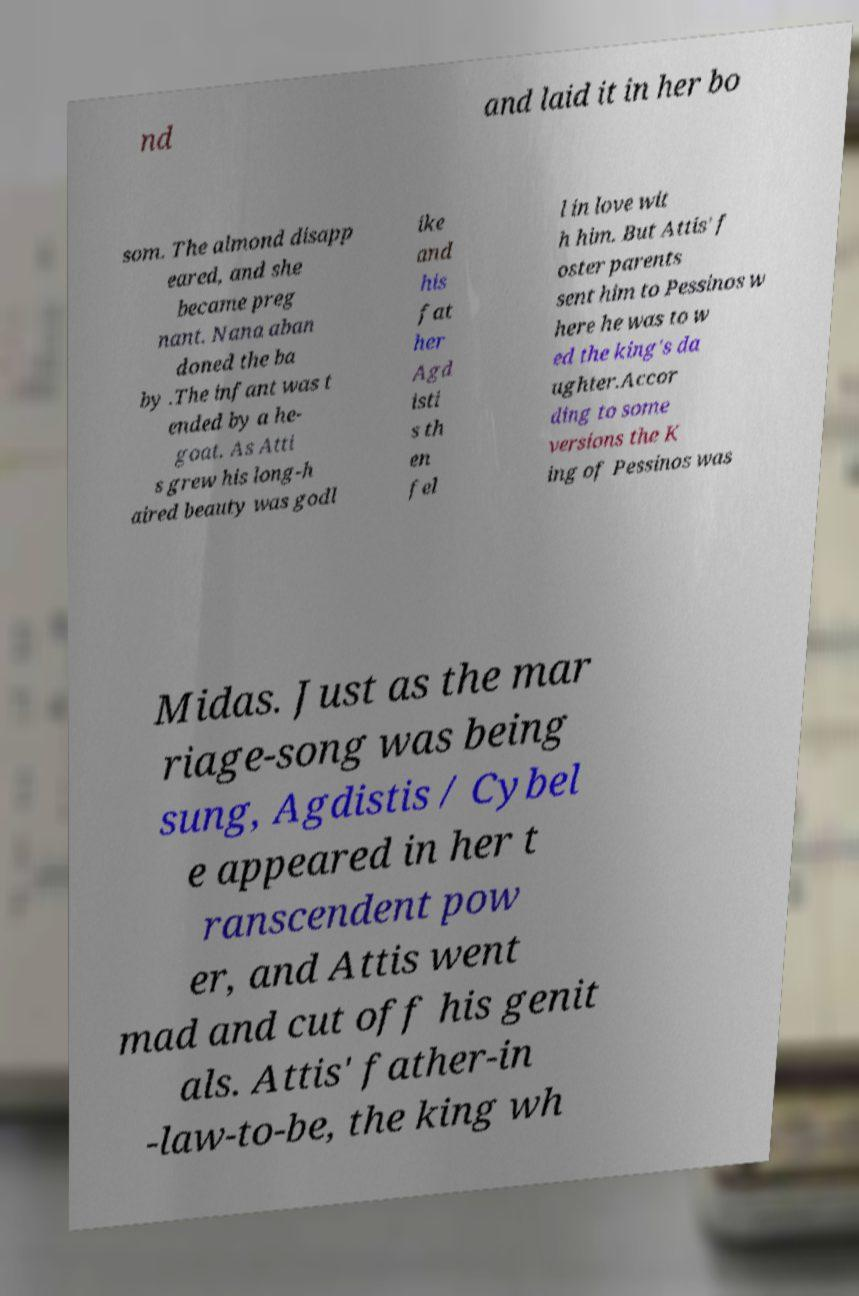Can you accurately transcribe the text from the provided image for me? nd and laid it in her bo som. The almond disapp eared, and she became preg nant. Nana aban doned the ba by .The infant was t ended by a he- goat. As Atti s grew his long-h aired beauty was godl ike and his fat her Agd isti s th en fel l in love wit h him. But Attis' f oster parents sent him to Pessinos w here he was to w ed the king's da ughter.Accor ding to some versions the K ing of Pessinos was Midas. Just as the mar riage-song was being sung, Agdistis / Cybel e appeared in her t ranscendent pow er, and Attis went mad and cut off his genit als. Attis' father-in -law-to-be, the king wh 